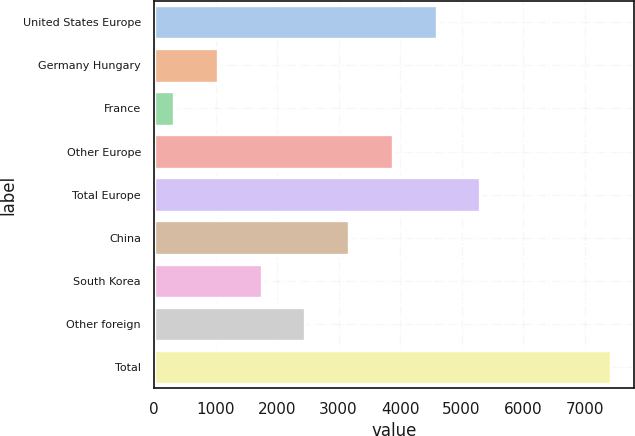<chart> <loc_0><loc_0><loc_500><loc_500><bar_chart><fcel>United States Europe<fcel>Germany Hungary<fcel>France<fcel>Other Europe<fcel>Total Europe<fcel>China<fcel>South Korea<fcel>Other foreign<fcel>Total<nl><fcel>4593<fcel>1038.5<fcel>327.6<fcel>3882.1<fcel>5303.9<fcel>3171.2<fcel>1749.4<fcel>2460.3<fcel>7436.6<nl></chart> 